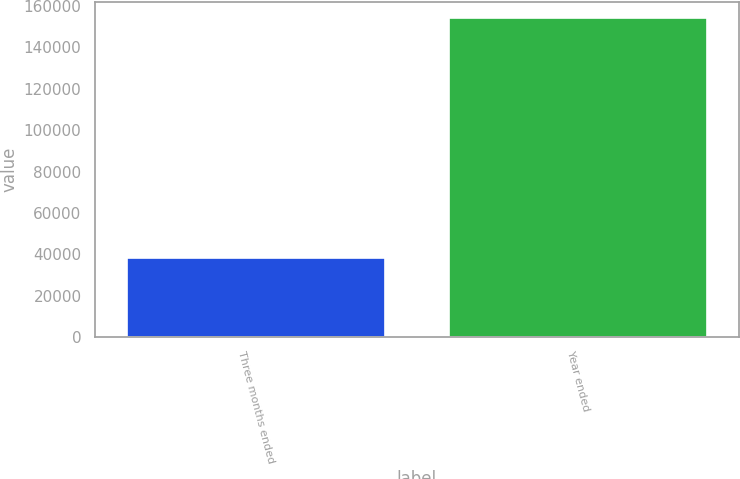Convert chart to OTSL. <chart><loc_0><loc_0><loc_500><loc_500><bar_chart><fcel>Three months ended<fcel>Year ended<nl><fcel>38194<fcel>154211<nl></chart> 